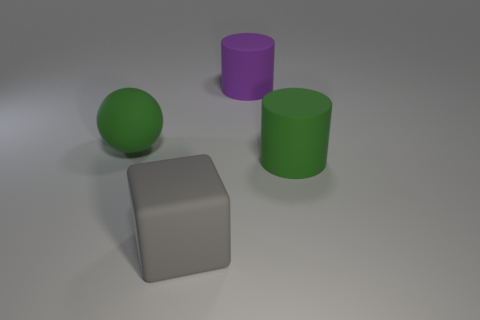What number of blocks are large green matte objects or big blue metal objects?
Your response must be concise. 0. What is the shape of the green object that is the same size as the green cylinder?
Your answer should be compact. Sphere. How many other objects are there of the same color as the large rubber ball?
Offer a very short reply. 1. What number of blue things are either rubber cylinders or tiny matte cubes?
Keep it short and to the point. 0. There is a green rubber object to the right of the ball; is its shape the same as the matte thing behind the large ball?
Make the answer very short. Yes. What number of other things are there of the same material as the big ball
Offer a very short reply. 3. There is a green object right of the object left of the big gray thing; is there a rubber thing in front of it?
Your response must be concise. Yes. Are there any other things that are the same shape as the big gray object?
Offer a very short reply. No. There is a cylinder behind the green matte object that is to the right of the large gray cube; what is its material?
Keep it short and to the point. Rubber. What size is the green matte thing that is on the left side of the cube?
Keep it short and to the point. Large. 